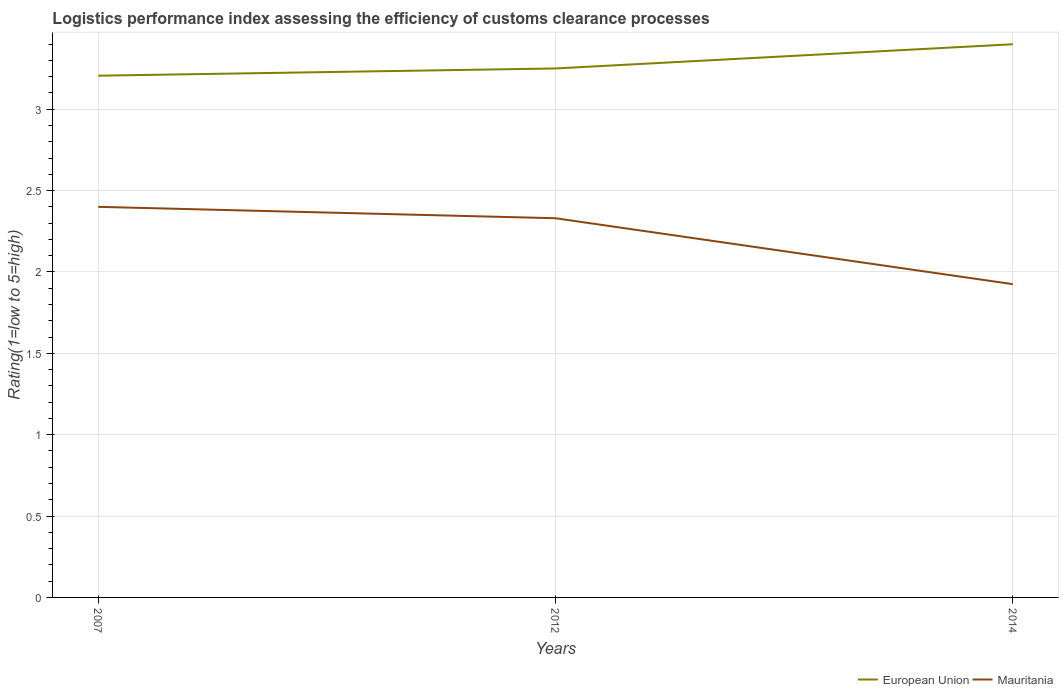Across all years, what is the maximum Logistic performance index in European Union?
Provide a succinct answer. 3.21. In which year was the Logistic performance index in Mauritania maximum?
Ensure brevity in your answer.  2014. What is the total Logistic performance index in Mauritania in the graph?
Your response must be concise. 0.41. What is the difference between the highest and the second highest Logistic performance index in European Union?
Your answer should be very brief. 0.19. Is the Logistic performance index in Mauritania strictly greater than the Logistic performance index in European Union over the years?
Your answer should be compact. Yes. How many lines are there?
Your answer should be very brief. 2. How many years are there in the graph?
Make the answer very short. 3. Does the graph contain any zero values?
Ensure brevity in your answer.  No. How many legend labels are there?
Offer a very short reply. 2. What is the title of the graph?
Make the answer very short. Logistics performance index assessing the efficiency of customs clearance processes. Does "Euro area" appear as one of the legend labels in the graph?
Offer a very short reply. No. What is the label or title of the X-axis?
Provide a succinct answer. Years. What is the label or title of the Y-axis?
Your answer should be compact. Rating(1=low to 5=high). What is the Rating(1=low to 5=high) of European Union in 2007?
Make the answer very short. 3.21. What is the Rating(1=low to 5=high) in Mauritania in 2007?
Offer a terse response. 2.4. What is the Rating(1=low to 5=high) in European Union in 2012?
Ensure brevity in your answer.  3.25. What is the Rating(1=low to 5=high) of Mauritania in 2012?
Your answer should be compact. 2.33. What is the Rating(1=low to 5=high) in European Union in 2014?
Your answer should be compact. 3.4. What is the Rating(1=low to 5=high) of Mauritania in 2014?
Offer a very short reply. 1.93. Across all years, what is the maximum Rating(1=low to 5=high) in European Union?
Make the answer very short. 3.4. Across all years, what is the minimum Rating(1=low to 5=high) in European Union?
Offer a very short reply. 3.21. Across all years, what is the minimum Rating(1=low to 5=high) in Mauritania?
Keep it short and to the point. 1.93. What is the total Rating(1=low to 5=high) of European Union in the graph?
Make the answer very short. 9.86. What is the total Rating(1=low to 5=high) of Mauritania in the graph?
Your answer should be compact. 6.66. What is the difference between the Rating(1=low to 5=high) in European Union in 2007 and that in 2012?
Your response must be concise. -0.04. What is the difference between the Rating(1=low to 5=high) in Mauritania in 2007 and that in 2012?
Give a very brief answer. 0.07. What is the difference between the Rating(1=low to 5=high) in European Union in 2007 and that in 2014?
Your answer should be very brief. -0.19. What is the difference between the Rating(1=low to 5=high) of Mauritania in 2007 and that in 2014?
Give a very brief answer. 0.47. What is the difference between the Rating(1=low to 5=high) of European Union in 2012 and that in 2014?
Your answer should be very brief. -0.15. What is the difference between the Rating(1=low to 5=high) of Mauritania in 2012 and that in 2014?
Make the answer very short. 0.41. What is the difference between the Rating(1=low to 5=high) of European Union in 2007 and the Rating(1=low to 5=high) of Mauritania in 2012?
Your response must be concise. 0.88. What is the difference between the Rating(1=low to 5=high) in European Union in 2007 and the Rating(1=low to 5=high) in Mauritania in 2014?
Provide a succinct answer. 1.28. What is the difference between the Rating(1=low to 5=high) of European Union in 2012 and the Rating(1=low to 5=high) of Mauritania in 2014?
Provide a short and direct response. 1.33. What is the average Rating(1=low to 5=high) of European Union per year?
Your response must be concise. 3.29. What is the average Rating(1=low to 5=high) in Mauritania per year?
Provide a succinct answer. 2.22. In the year 2007, what is the difference between the Rating(1=low to 5=high) in European Union and Rating(1=low to 5=high) in Mauritania?
Keep it short and to the point. 0.81. In the year 2012, what is the difference between the Rating(1=low to 5=high) in European Union and Rating(1=low to 5=high) in Mauritania?
Your response must be concise. 0.92. In the year 2014, what is the difference between the Rating(1=low to 5=high) in European Union and Rating(1=low to 5=high) in Mauritania?
Offer a very short reply. 1.47. What is the ratio of the Rating(1=low to 5=high) of European Union in 2007 to that in 2012?
Provide a succinct answer. 0.99. What is the ratio of the Rating(1=low to 5=high) of European Union in 2007 to that in 2014?
Keep it short and to the point. 0.94. What is the ratio of the Rating(1=low to 5=high) in Mauritania in 2007 to that in 2014?
Ensure brevity in your answer.  1.25. What is the ratio of the Rating(1=low to 5=high) of European Union in 2012 to that in 2014?
Keep it short and to the point. 0.96. What is the ratio of the Rating(1=low to 5=high) of Mauritania in 2012 to that in 2014?
Offer a terse response. 1.21. What is the difference between the highest and the second highest Rating(1=low to 5=high) of European Union?
Keep it short and to the point. 0.15. What is the difference between the highest and the second highest Rating(1=low to 5=high) of Mauritania?
Your answer should be compact. 0.07. What is the difference between the highest and the lowest Rating(1=low to 5=high) of European Union?
Keep it short and to the point. 0.19. What is the difference between the highest and the lowest Rating(1=low to 5=high) in Mauritania?
Give a very brief answer. 0.47. 